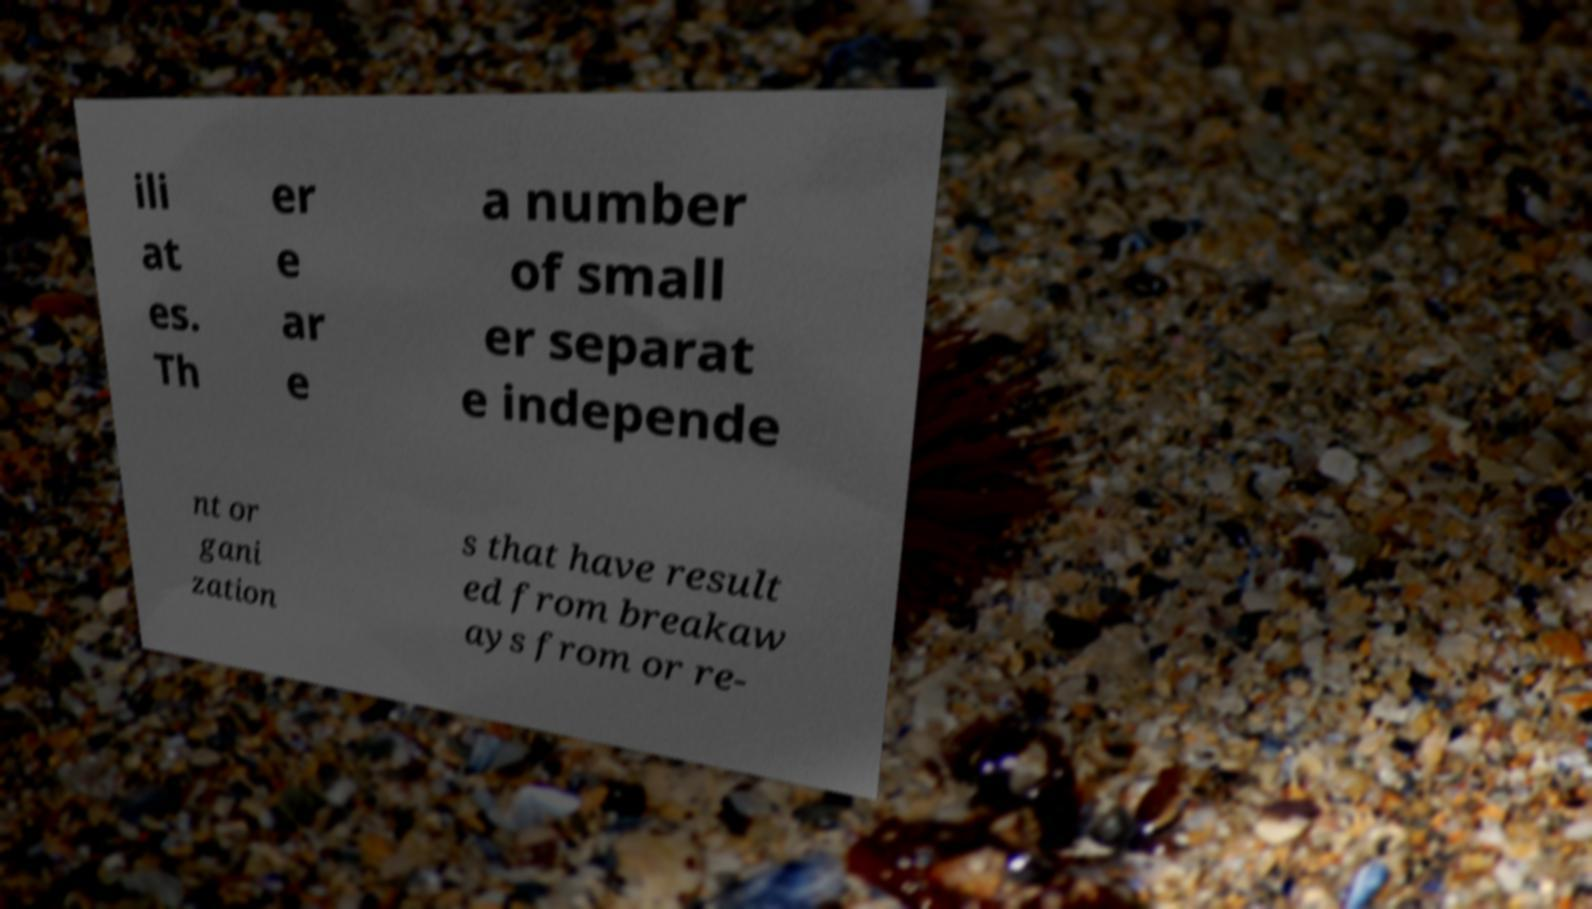Please identify and transcribe the text found in this image. ili at es. Th er e ar e a number of small er separat e independe nt or gani zation s that have result ed from breakaw ays from or re- 